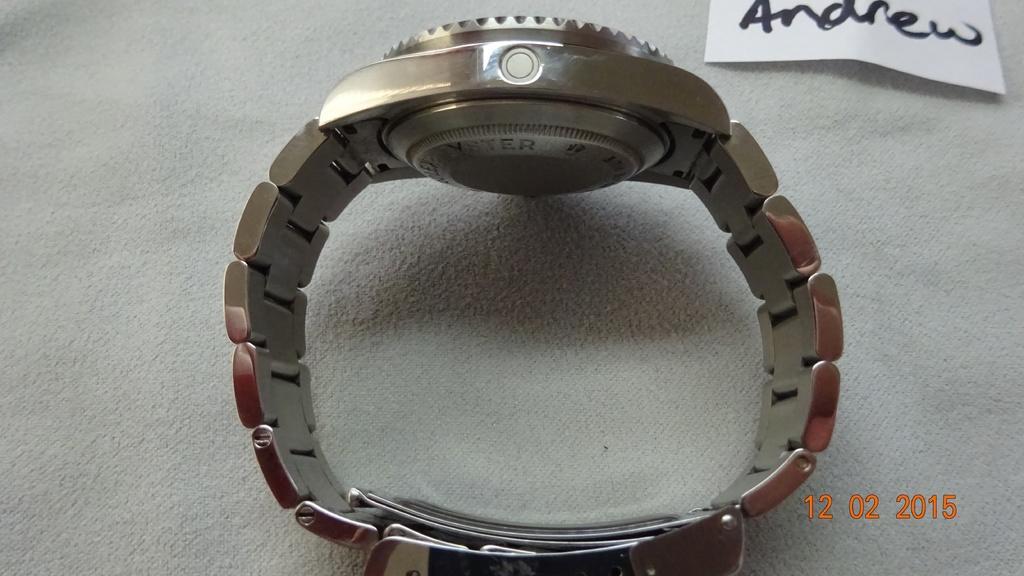Please provide a concise description of this image. A watch is placed on a white cloth. There is a white note on which 'andrew' is written. 